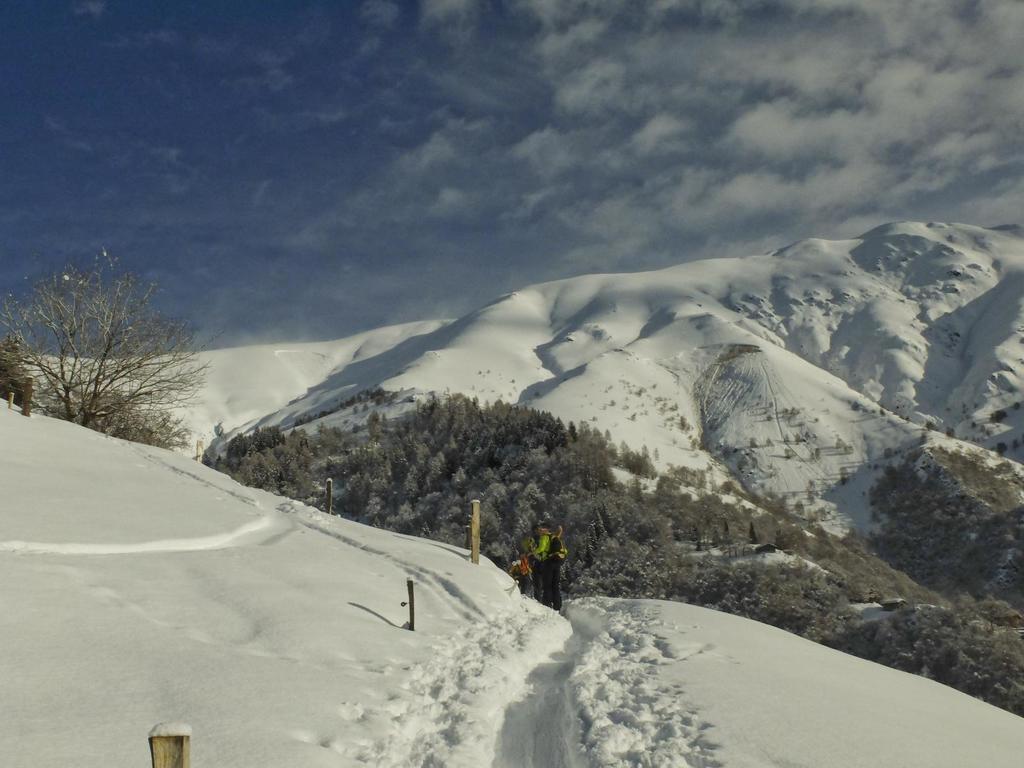How would you summarize this image in a sentence or two? In this picture we can see few people on the snow, in the background we can find few trees and clouds. 